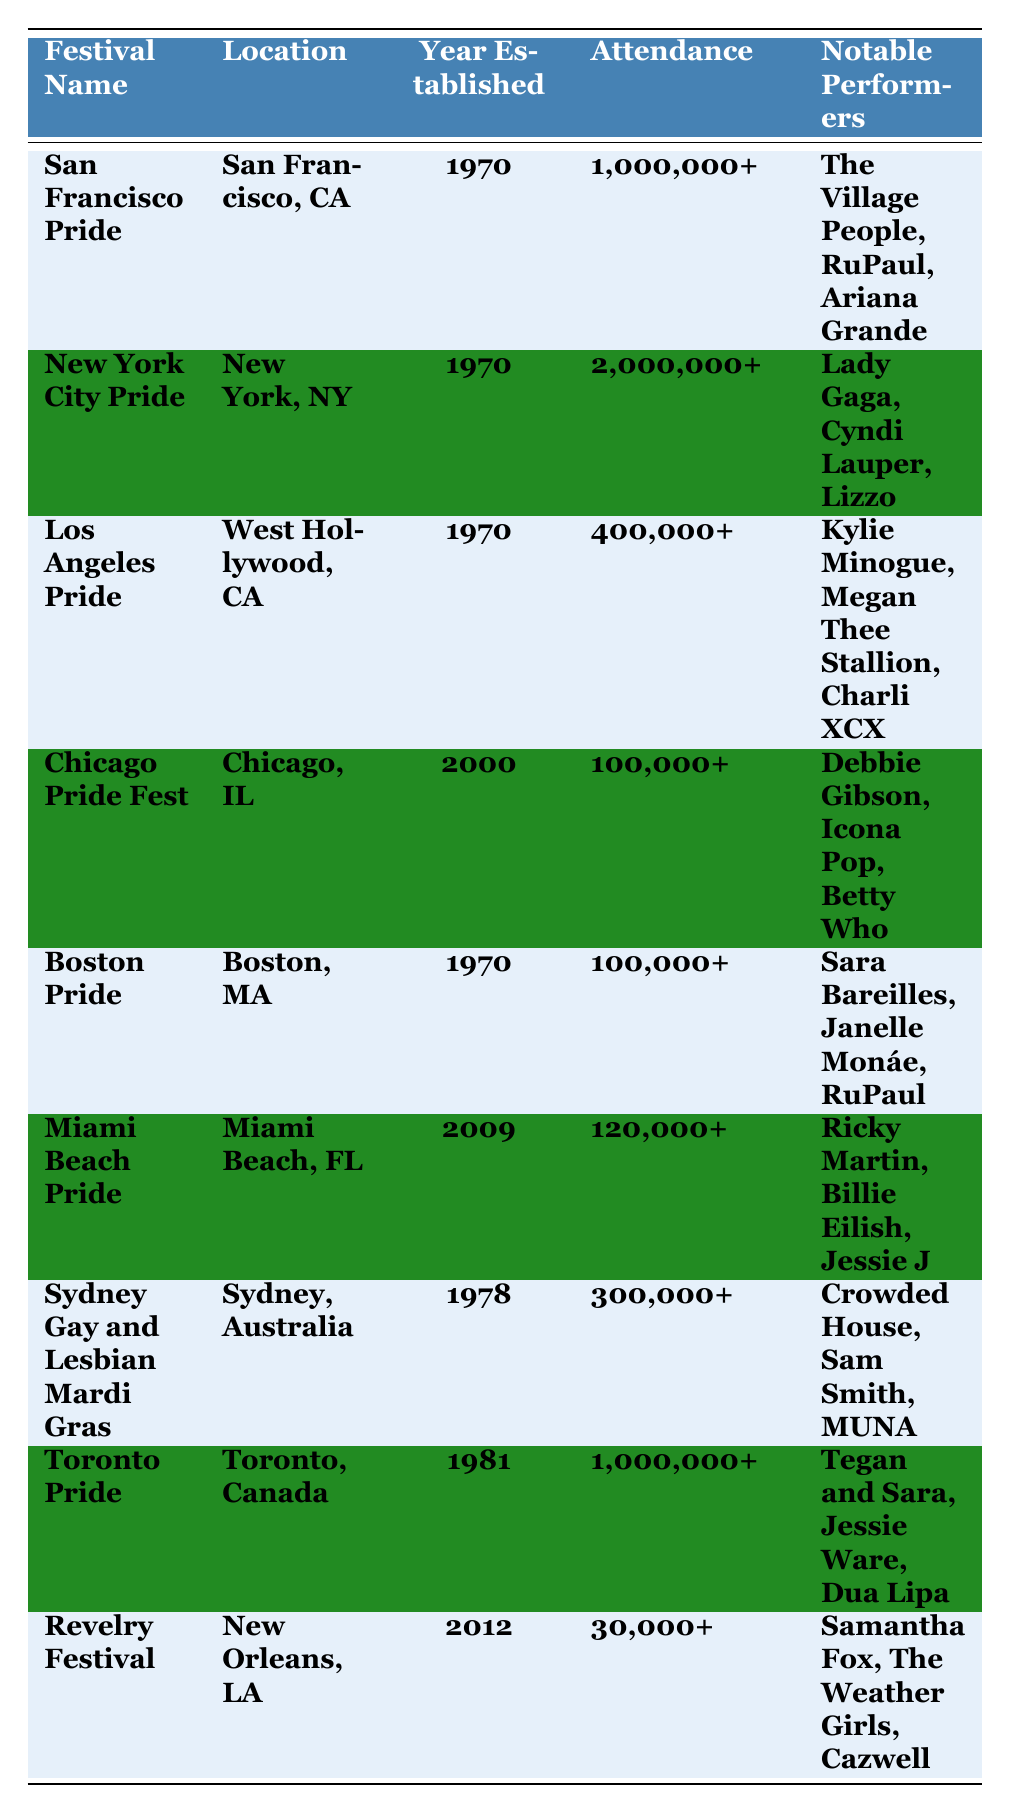What year was Toronto Pride established? Toronto Pride is listed in the table, and its year established is directly provided as 1981.
Answer: 1981 Which festival has the highest attendance? From the table, the attendance for New York City Pride is 2,000,000+, which is the highest compared to other festivals.
Answer: 2,000,000+ What notable performers participated in San Francisco Pride? The table shows that notable performers at San Francisco Pride include The Village People, RuPaul, and Ariana Grande.
Answer: The Village People, RuPaul, Ariana Grande Is Miami Beach Pride one of the older festivals established before 2000? Miami Beach Pride was established in 2009, which is after 2000; thus, it is not one of the older festivals.
Answer: No How many festivals have attendances greater than 300,000? The table shows New York City Pride (2,000,000+), San Francisco Pride (1,000,000+), and Los Angeles Pride (400,000+). This totals three festivals.
Answer: 3 Which festival has the same year established as both San Francisco Pride and New York City Pride? Both San Francisco Pride and New York City Pride were established in 1970, and Los Angeles Pride also shares the same year of establishment.
Answer: Los Angeles Pride What is the total attendance of the five festivals established in the 1970s? The festivals are San Francisco Pride (1,000,000+), New York City Pride (2,000,000+), Los Angeles Pride (400,000+), Boston Pride (100,000+), and Sydney Gay and Lesbian Mardi Gras (300,000+). Adding these: 1,000,000 + 2,000,000 + 400,000 + 100,000 + 300,000 = 3,800,000.
Answer: 3,800,000+ Which festival features performers like Tegan and Sara and Dua Lipa? The table specifies that Toronto Pride features Tegan and Sara and Dua Lipa among its notable performers.
Answer: Toronto Pride Does Chicago Pride Fest have an attendance that exceeds 150,000? The table states that Chicago Pride Fest has an attendance of 100,000+, which does not exceed 150,000.
Answer: No What’s the difference in attendance between New York City Pride and Miami Beach Pride? The attendance for New York City Pride is 2,000,000+ and for Miami Beach Pride is 120,000+. The difference is calculated as 2,000,000 - 120,000 = 1,880,000.
Answer: 1,880,000 